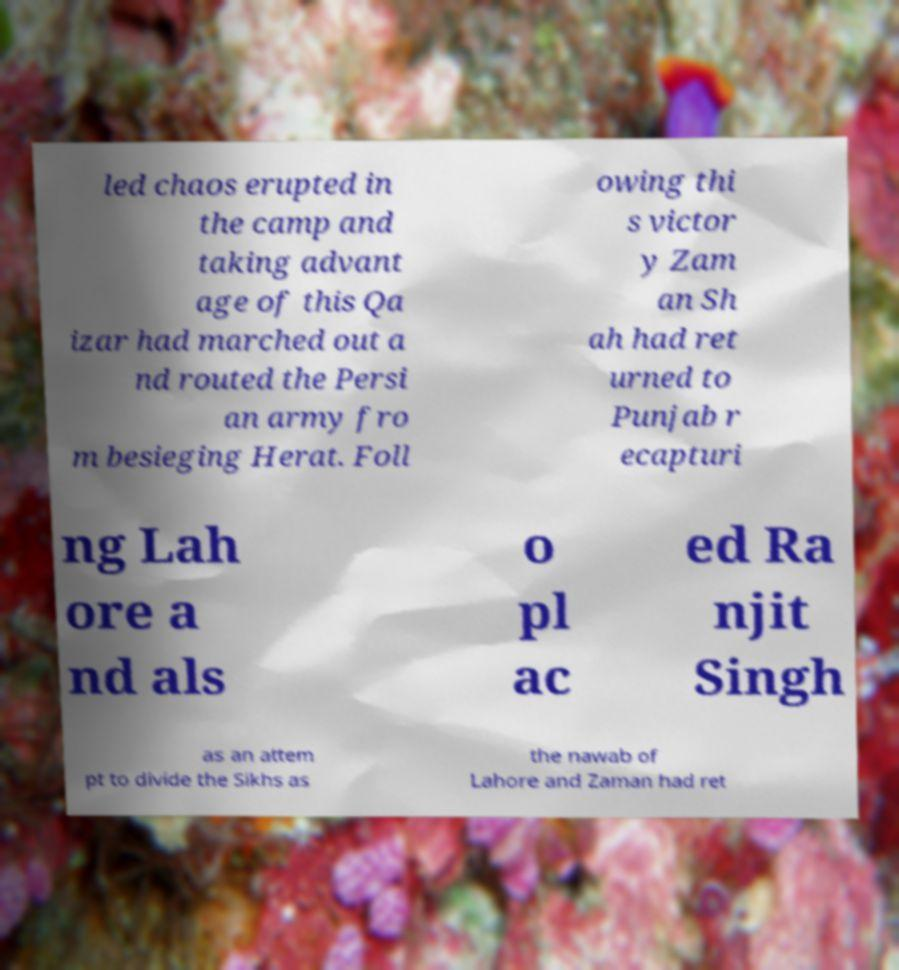Could you assist in decoding the text presented in this image and type it out clearly? led chaos erupted in the camp and taking advant age of this Qa izar had marched out a nd routed the Persi an army fro m besieging Herat. Foll owing thi s victor y Zam an Sh ah had ret urned to Punjab r ecapturi ng Lah ore a nd als o pl ac ed Ra njit Singh as an attem pt to divide the Sikhs as the nawab of Lahore and Zaman had ret 